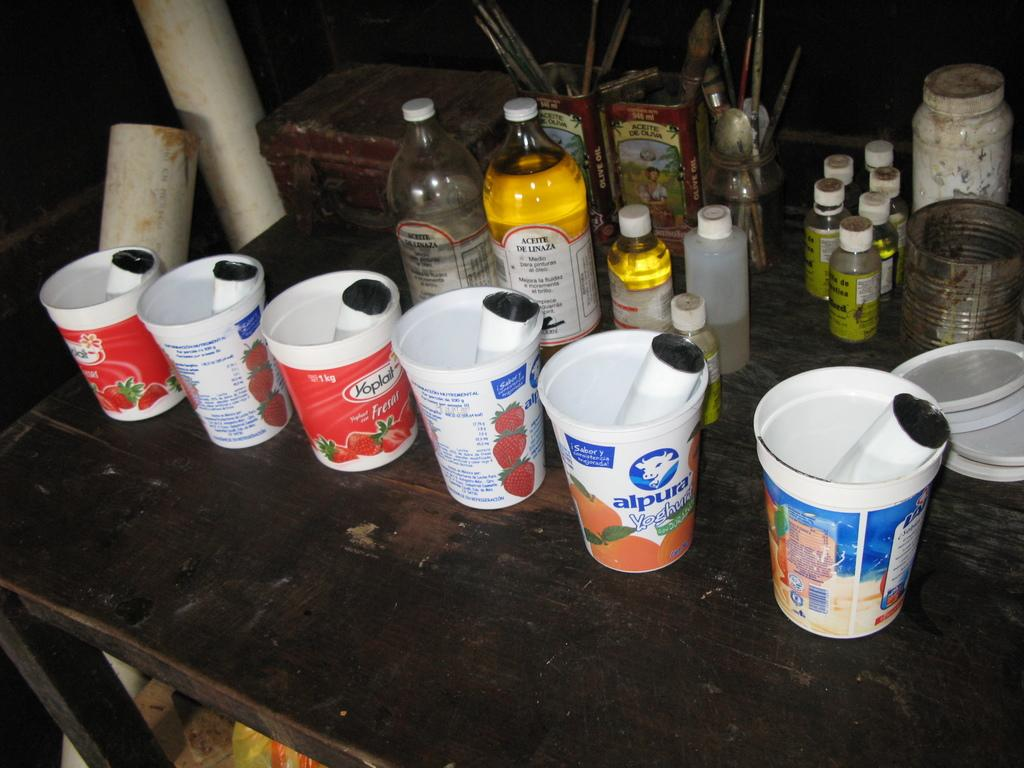<image>
Write a terse but informative summary of the picture. Cups of yogurt including one that says Alpura on it. 